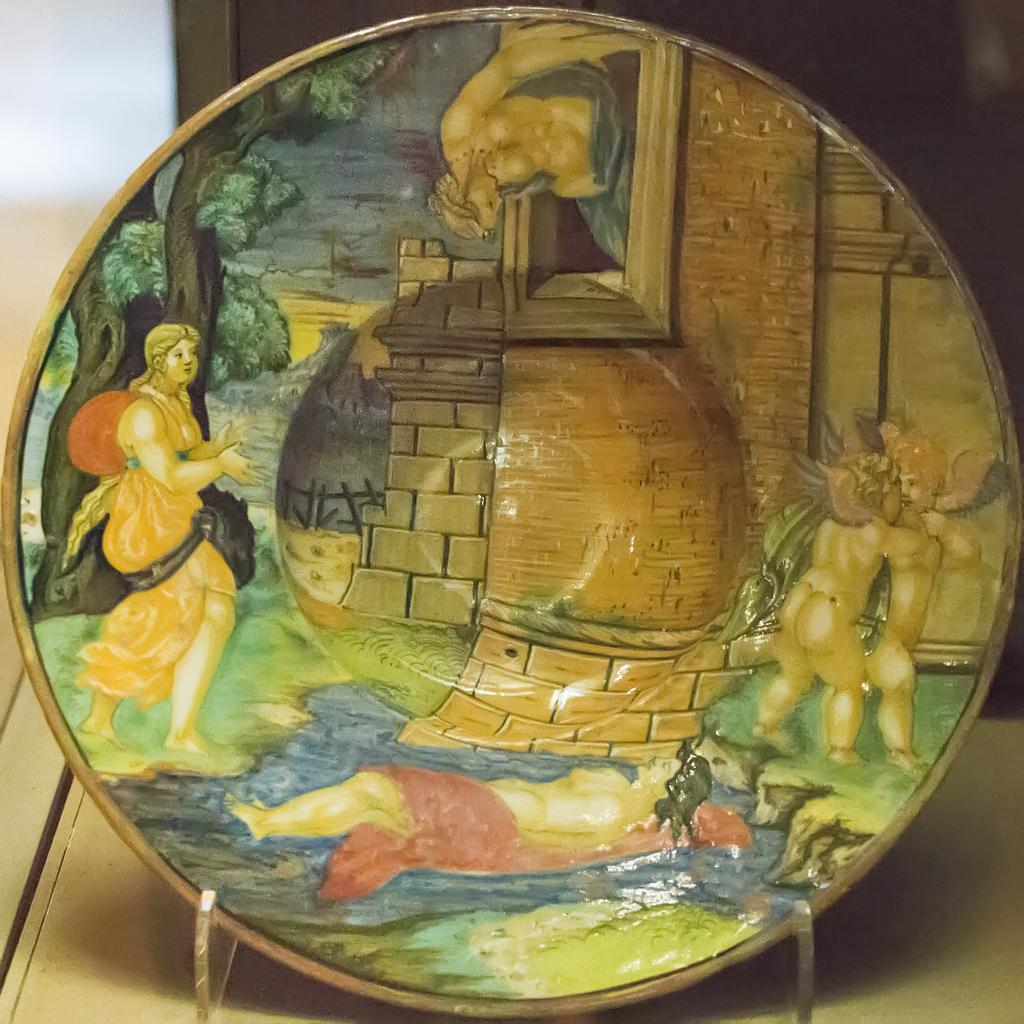What type of object is made of porcelain in the image? There is a porcelain object in the image, but the specific type is not mentioned. How is the porcelain object displayed or supported? The porcelain object is in a stand. Where is the stand with the porcelain object located? The stand with the porcelain object is placed on a table. What type of key is used to open the hall in the image? There is no mention of a key or a hall in the image; it only features a porcelain object in a stand on a table. 